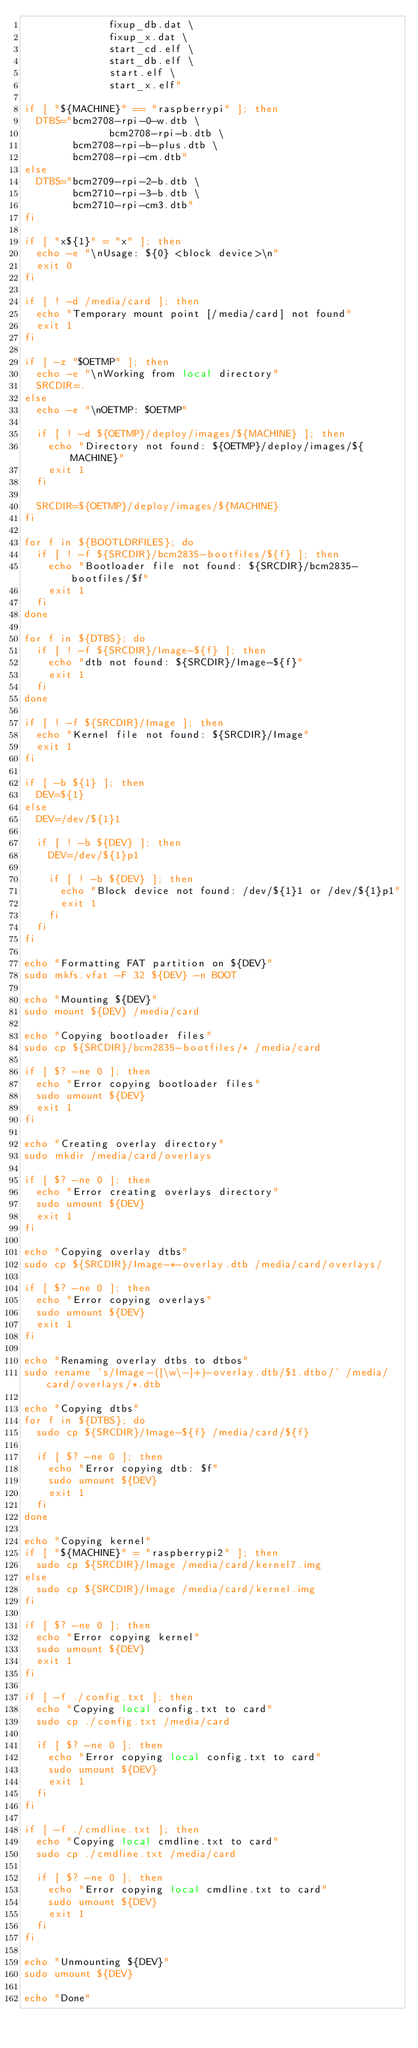<code> <loc_0><loc_0><loc_500><loc_500><_Bash_>              fixup_db.dat \
              fixup_x.dat \
              start_cd.elf \
              start_db.elf \
              start.elf \
              start_x.elf"

if [ "${MACHINE}" == "raspberrypi" ]; then
	DTBS="bcm2708-rpi-0-w.dtb \
              bcm2708-rpi-b.dtb \
	      bcm2708-rpi-b-plus.dtb \
	      bcm2708-rpi-cm.dtb"
else
	DTBS="bcm2709-rpi-2-b.dtb \
	      bcm2710-rpi-3-b.dtb \
	      bcm2710-rpi-cm3.dtb"
fi

if [ "x${1}" = "x" ]; then
	echo -e "\nUsage: ${0} <block device>\n"
	exit 0
fi

if [ ! -d /media/card ]; then
	echo "Temporary mount point [/media/card] not found"
	exit 1
fi

if [ -z "$OETMP" ]; then
	echo -e "\nWorking from local directory"
	SRCDIR=.
else
	echo -e "\nOETMP: $OETMP"

	if [ ! -d ${OETMP}/deploy/images/${MACHINE} ]; then
		echo "Directory not found: ${OETMP}/deploy/images/${MACHINE}"
		exit 1
	fi

	SRCDIR=${OETMP}/deploy/images/${MACHINE}
fi 

for f in ${BOOTLDRFILES}; do
	if [ ! -f ${SRCDIR}/bcm2835-bootfiles/${f} ]; then
		echo "Bootloader file not found: ${SRCDIR}/bcm2835-bootfiles/$f"
		exit 1
	fi
done

for f in ${DTBS}; do
	if [ ! -f ${SRCDIR}/Image-${f} ]; then
		echo "dtb not found: ${SRCDIR}/Image-${f}"
		exit 1
	fi
done
	
if [ ! -f ${SRCDIR}/Image ]; then
	echo "Kernel file not found: ${SRCDIR}/Image"
	exit 1
fi

if [ -b ${1} ]; then
	DEV=${1}
else
	DEV=/dev/${1}1

	if [ ! -b ${DEV} ]; then
		DEV=/dev/${1}p1

		if [ ! -b ${DEV} ]; then
			echo "Block device not found: /dev/${1}1 or /dev/${1}p1"
			exit 1
		fi
	fi
fi

echo "Formatting FAT partition on ${DEV}"
sudo mkfs.vfat -F 32 ${DEV} -n BOOT

echo "Mounting ${DEV}"
sudo mount ${DEV} /media/card

echo "Copying bootloader files"
sudo cp ${SRCDIR}/bcm2835-bootfiles/* /media/card

if [ $? -ne 0 ]; then
	echo "Error copying bootloader files"
	sudo umount ${DEV}
	exit 1
fi

echo "Creating overlay directory"
sudo mkdir /media/card/overlays

if [ $? -ne 0 ]; then
	echo "Error creating overlays directory"
	sudo umount ${DEV}
	exit 1
fi

echo "Copying overlay dtbs"
sudo cp ${SRCDIR}/Image-*-overlay.dtb /media/card/overlays/

if [ $? -ne 0 ]; then
	echo "Error copying overlays"
	sudo umount ${DEV}
	exit 1
fi

echo "Renaming overlay dtbs to dtbos"
sudo rename 's/Image-([\w\-]+)-overlay.dtb/$1.dtbo/' /media/card/overlays/*.dtb

echo "Copying dtbs"
for f in ${DTBS}; do
	sudo cp ${SRCDIR}/Image-${f} /media/card/${f}

	if [ $? -ne 0 ]; then
		echo "Error copying dtb: $f"
		sudo umount ${DEV}
		exit 1
	fi
done

echo "Copying kernel"
if [ "${MACHINE}" = "raspberrypi2" ]; then 
	sudo cp ${SRCDIR}/Image /media/card/kernel7.img
else
	sudo cp ${SRCDIR}/Image /media/card/kernel.img
fi

if [ $? -ne 0 ]; then
	echo "Error copying kernel"
	sudo umount ${DEV}
	exit 1
fi

if [ -f ./config.txt ]; then
	echo "Copying local config.txt to card"
	sudo cp ./config.txt /media/card

	if [ $? -ne 0 ]; then
		echo "Error copying local config.txt to card"
		sudo umount ${DEV}
		exit 1
	fi
fi
  
if [ -f ./cmdline.txt ]; then
	echo "Copying local cmdline.txt to card"
	sudo cp ./cmdline.txt /media/card

	if [ $? -ne 0 ]; then
		echo "Error copying local cmdline.txt to card"
		sudo umount ${DEV}
		exit 1
	fi
fi

echo "Unmounting ${DEV}"
sudo umount ${DEV}

echo "Done"

</code> 